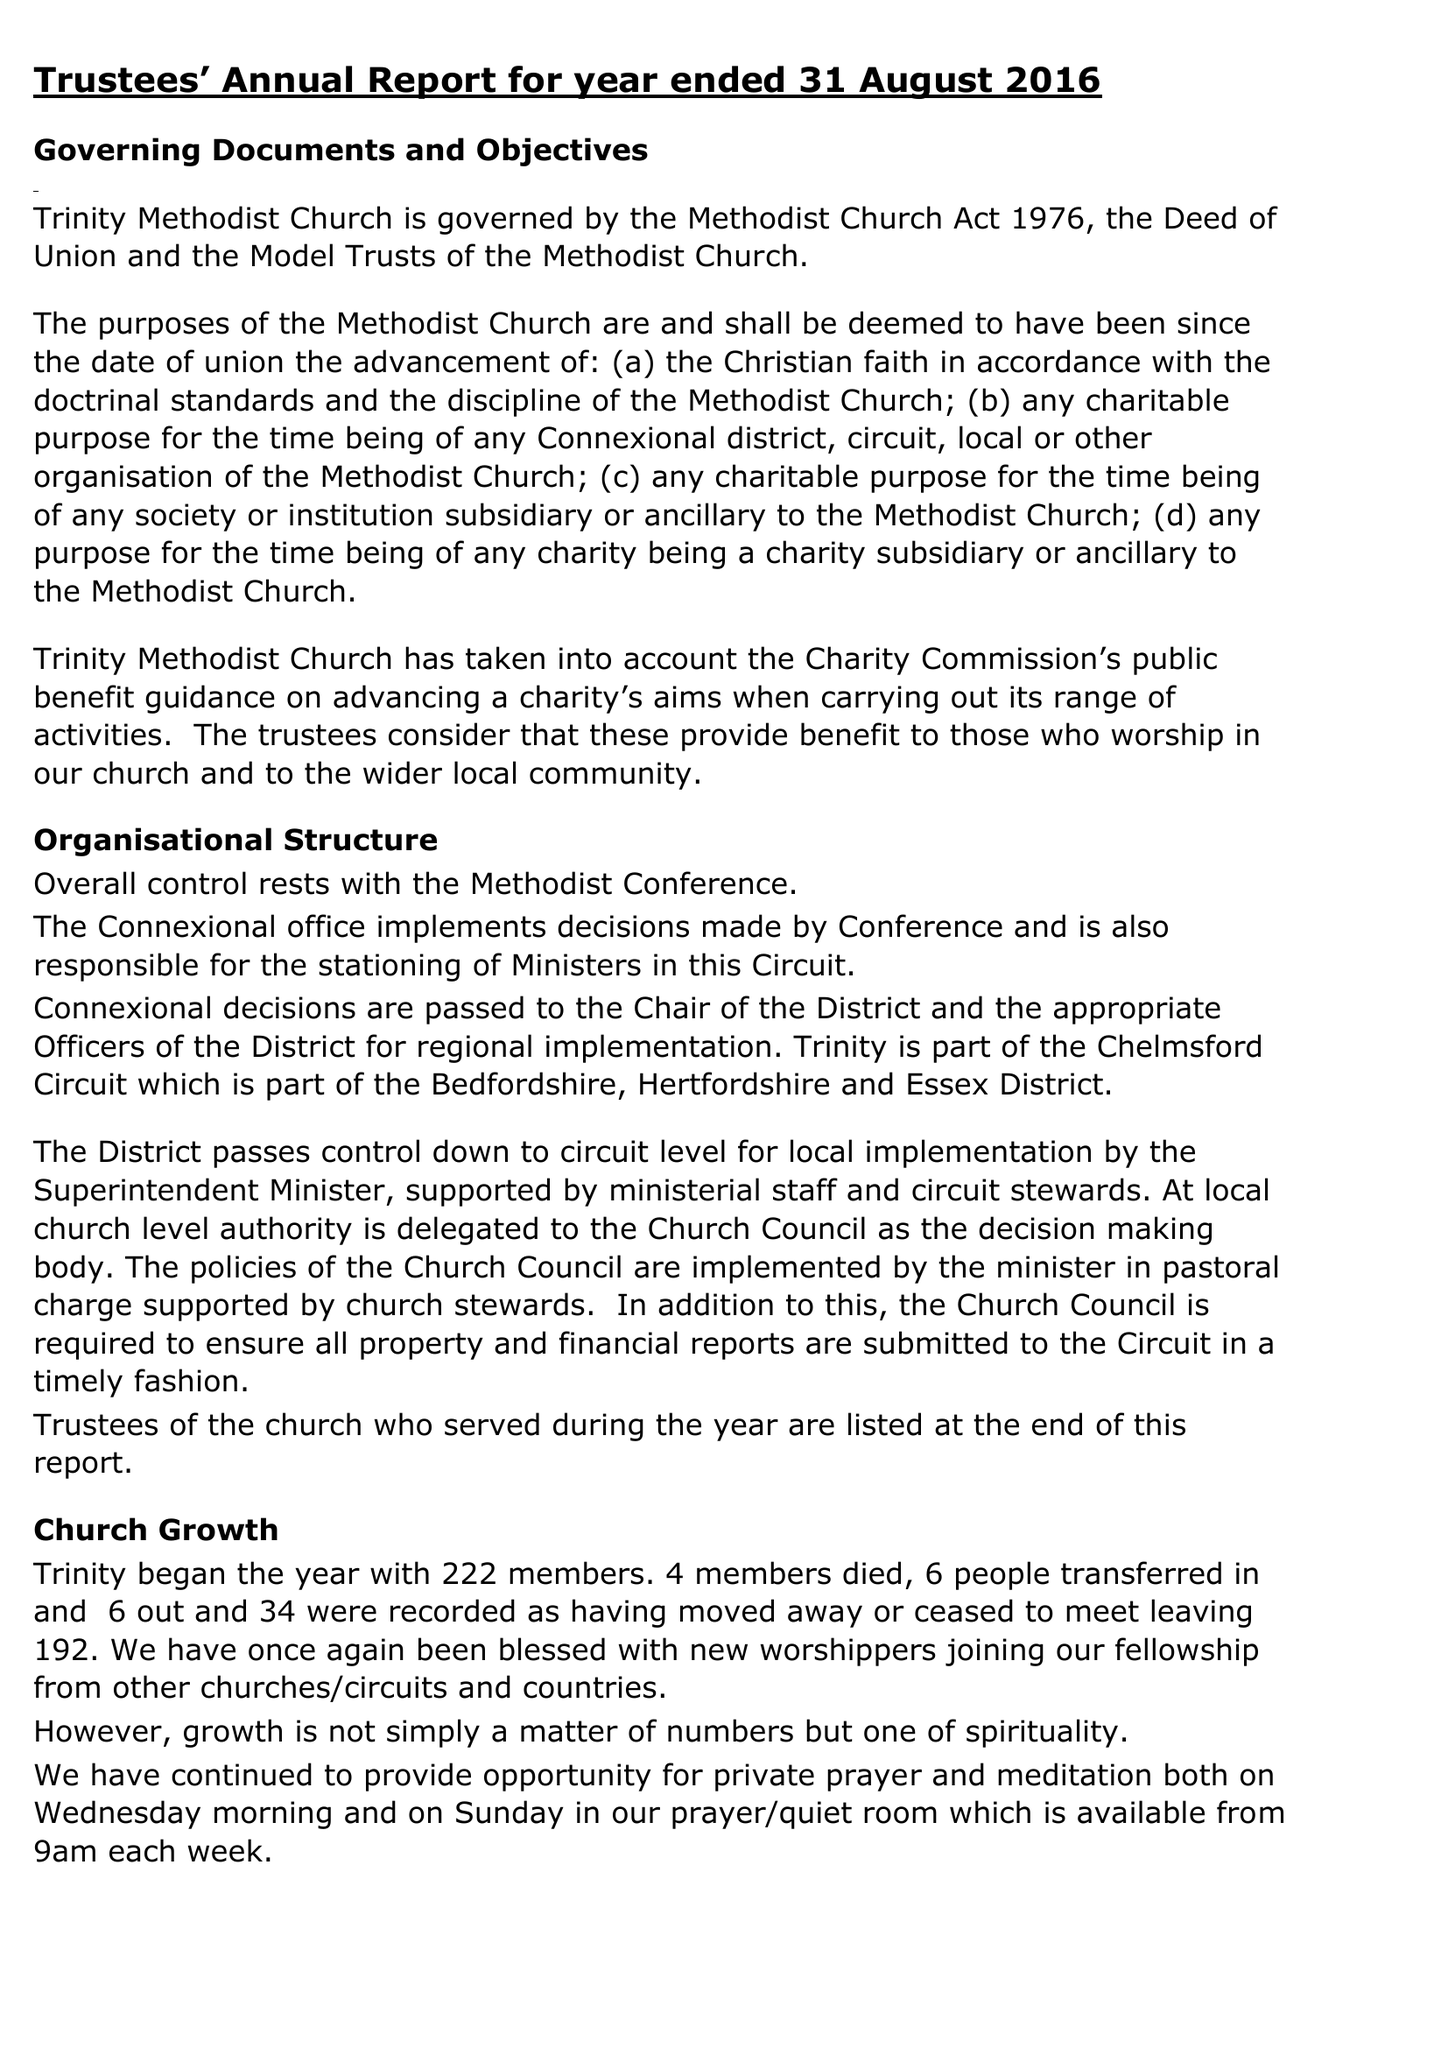What is the value for the spending_annually_in_british_pounds?
Answer the question using a single word or phrase. 144284.00 